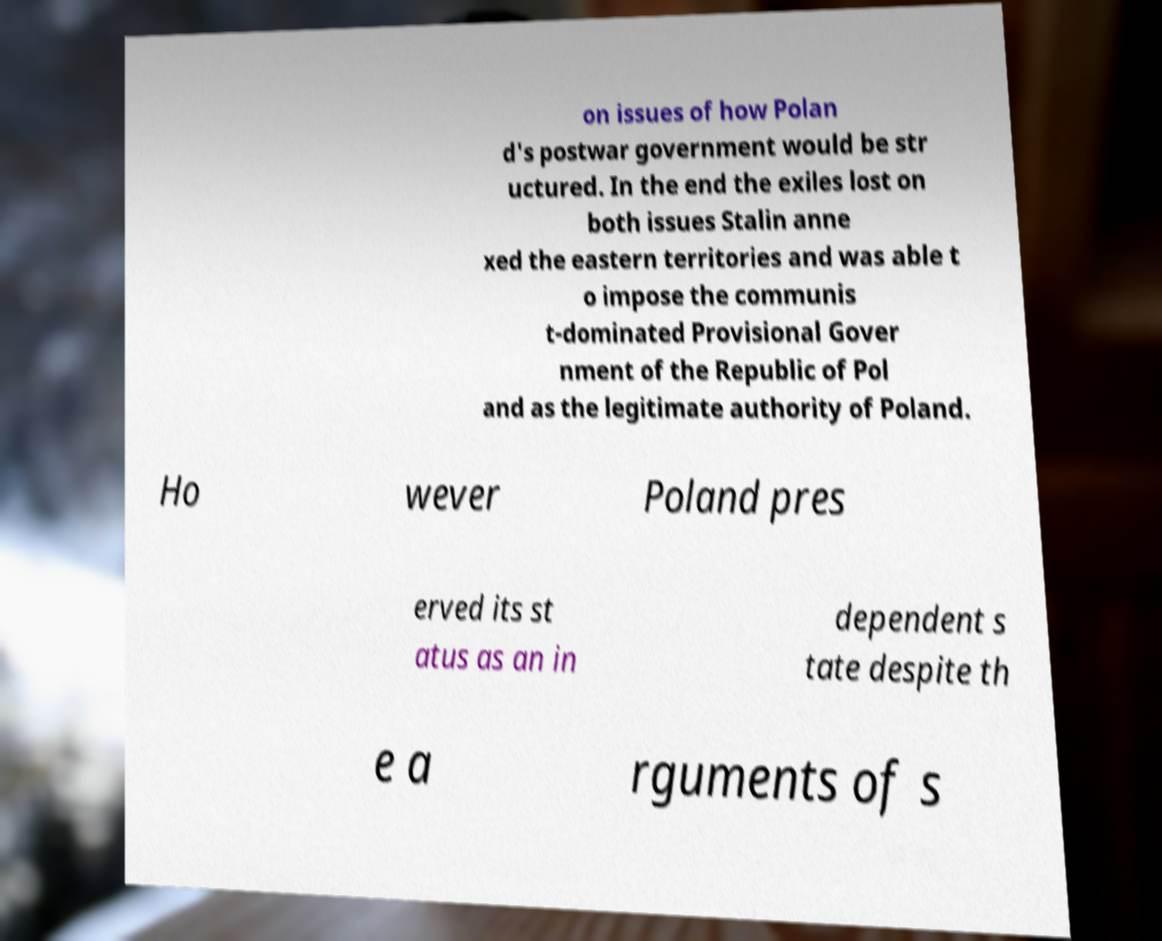Please identify and transcribe the text found in this image. on issues of how Polan d's postwar government would be str uctured. In the end the exiles lost on both issues Stalin anne xed the eastern territories and was able t o impose the communis t-dominated Provisional Gover nment of the Republic of Pol and as the legitimate authority of Poland. Ho wever Poland pres erved its st atus as an in dependent s tate despite th e a rguments of s 